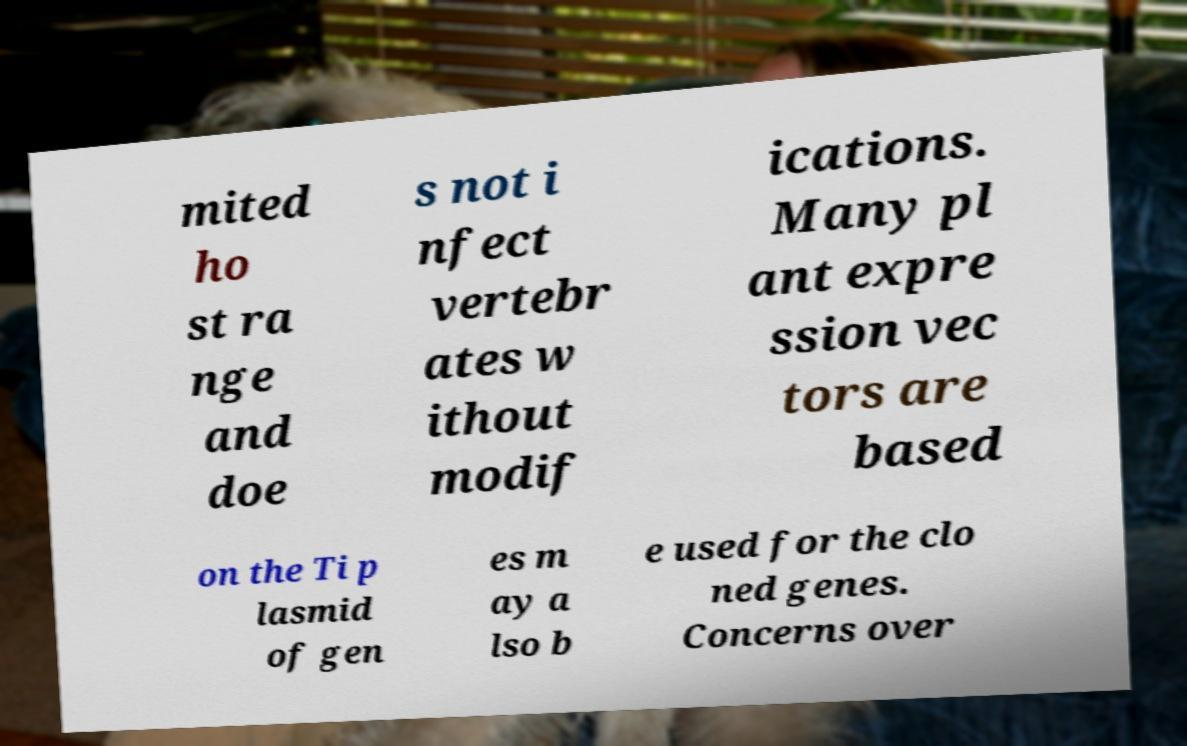Could you assist in decoding the text presented in this image and type it out clearly? mited ho st ra nge and doe s not i nfect vertebr ates w ithout modif ications. Many pl ant expre ssion vec tors are based on the Ti p lasmid of gen es m ay a lso b e used for the clo ned genes. Concerns over 